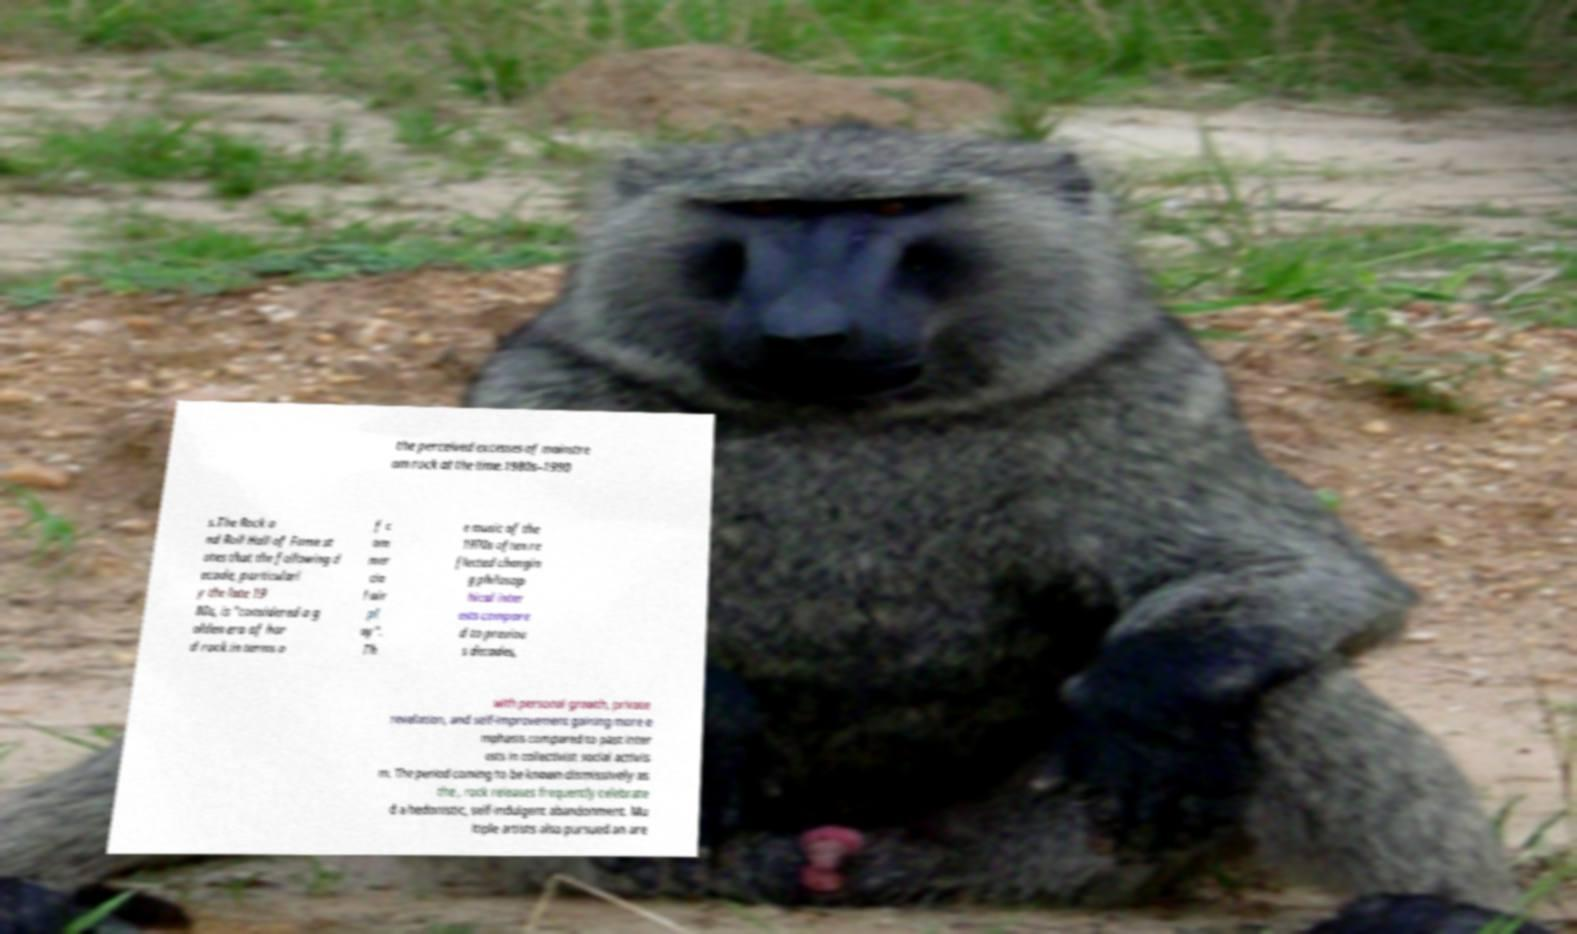There's text embedded in this image that I need extracted. Can you transcribe it verbatim? the perceived excesses of mainstre am rock at the time.1980s–1990 s.The Rock a nd Roll Hall of Fame st ates that the following d ecade, particularl y the late 19 80s, is "considered a g olden era of har d rock in terms o f c om mer cia l air pl ay". Th e music of the 1970s often re flected changin g philosop hical inter ests compare d to previou s decades, with personal growth, private revelation, and self-improvement gaining more e mphasis compared to past inter ests in collectivist social activis m. The period coming to be known dismissively as the , rock releases frequently celebrate d a hedonistic, self-indulgent abandonment. Mu ltiple artists also pursued an are 